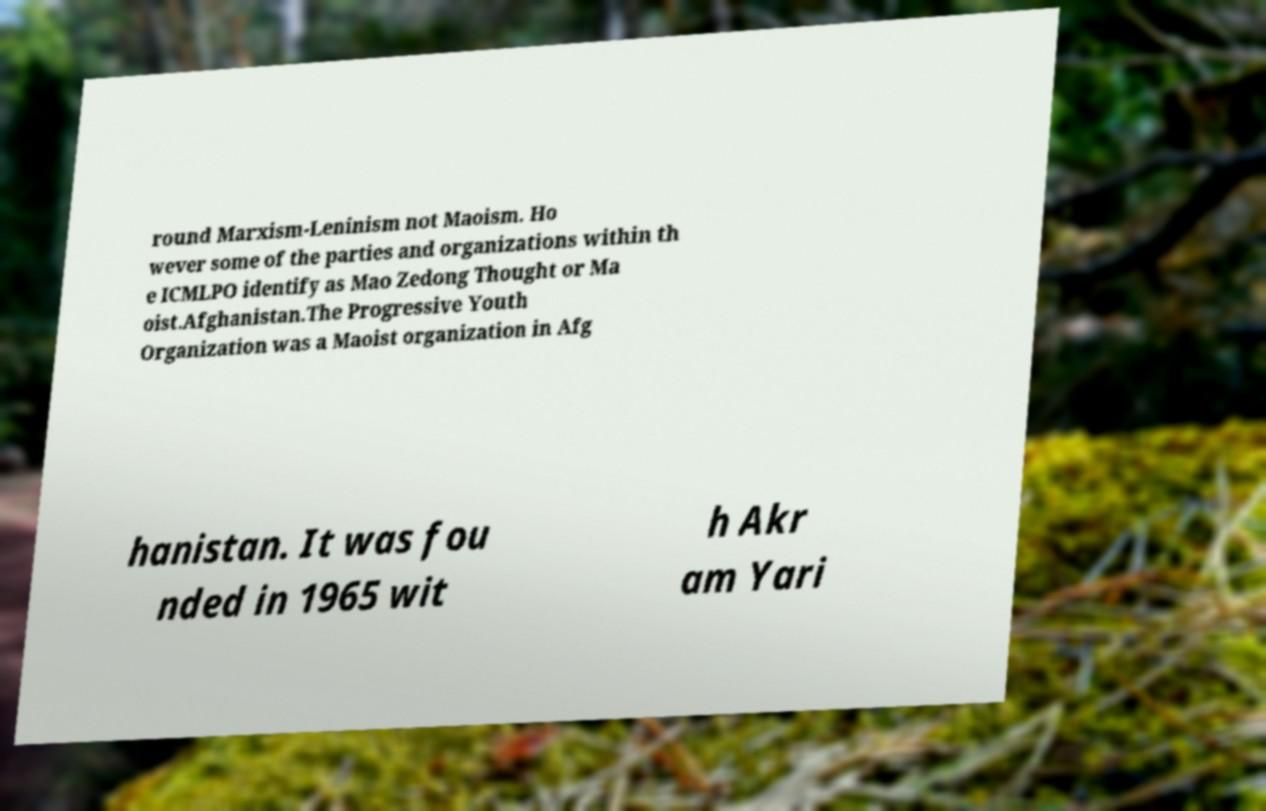Please read and relay the text visible in this image. What does it say? round Marxism-Leninism not Maoism. Ho wever some of the parties and organizations within th e ICMLPO identify as Mao Zedong Thought or Ma oist.Afghanistan.The Progressive Youth Organization was a Maoist organization in Afg hanistan. It was fou nded in 1965 wit h Akr am Yari 